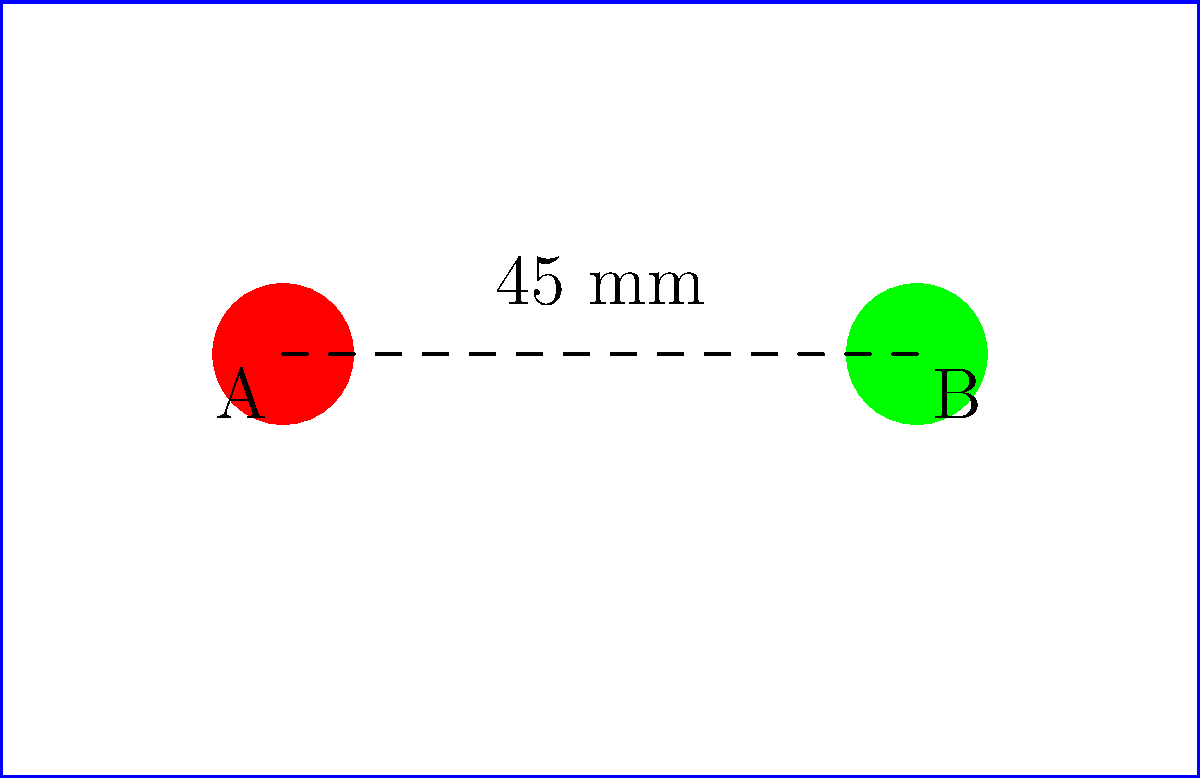You're designing a new business card for your bar. The logo, represented by a red circle (point A), needs to be moved 45 mm to the right on the business card template. What transformation would you use to move the logo to its new position (point B), and what are the coordinates of the translation vector? To solve this problem, we need to follow these steps:

1. Identify the transformation: The logo is being moved in a straight line without rotation or scaling, so this is a translation.

2. Determine the direction and distance of the movement:
   - The logo moves from left to right (positive x-direction)
   - The distance given is 45 mm

3. Identify the change in coordinates:
   - There is no vertical movement, so the y-coordinate doesn't change (0 mm)
   - The horizontal movement is 45 mm to the right (positive x-direction)

4. Express the translation as a vector:
   - The translation vector is represented as $(x, y)$ where $x$ is the horizontal movement and $y$ is the vertical movement
   - In this case, the vector is $(45, 0)$

Therefore, the transformation used is a translation with a vector of $(45, 0)$ mm.
Answer: Translation vector: $(45, 0)$ mm 